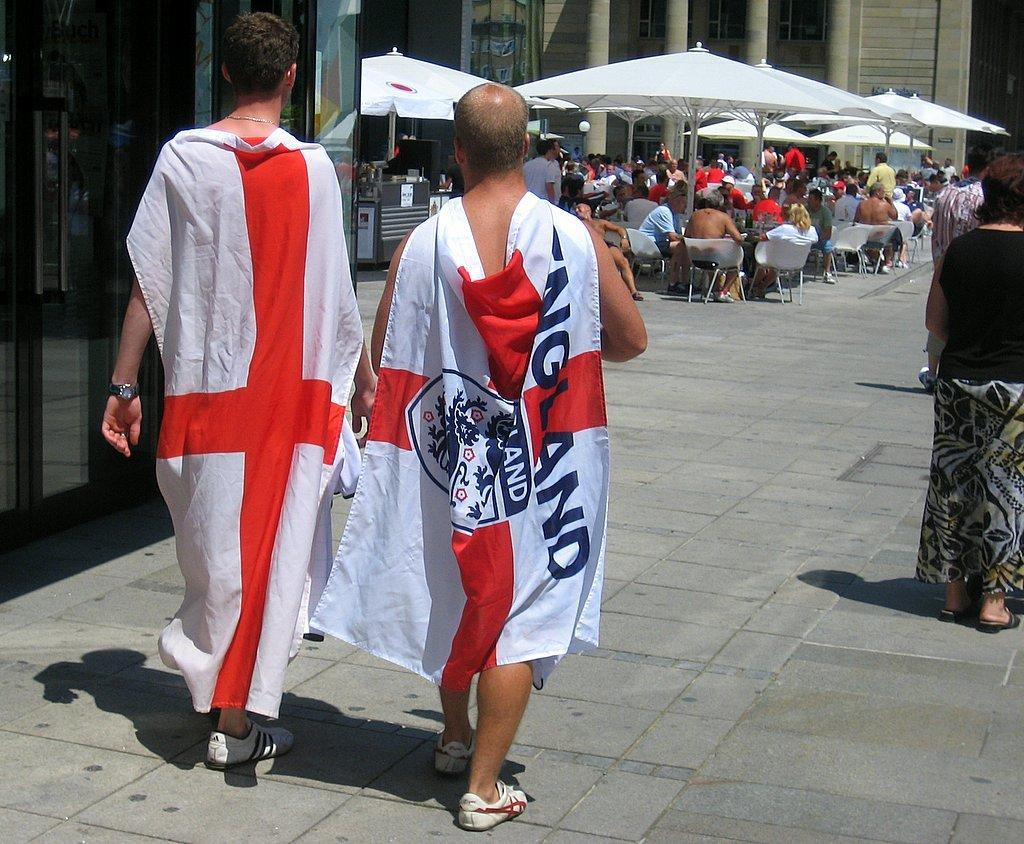<image>
Give a short and clear explanation of the subsequent image. A man wearing a flag that says England as a cape. 